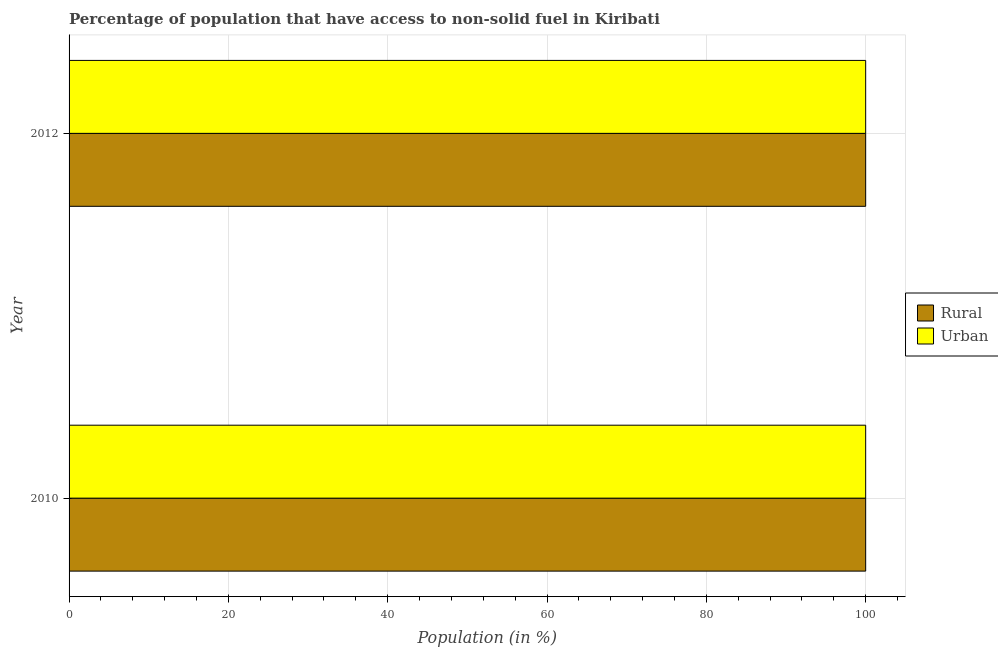How many different coloured bars are there?
Offer a terse response. 2. Are the number of bars per tick equal to the number of legend labels?
Make the answer very short. Yes. How many bars are there on the 1st tick from the bottom?
Keep it short and to the point. 2. What is the urban population in 2012?
Your answer should be very brief. 100. Across all years, what is the maximum urban population?
Offer a terse response. 100. Across all years, what is the minimum urban population?
Ensure brevity in your answer.  100. In which year was the urban population minimum?
Offer a terse response. 2010. What is the total urban population in the graph?
Your response must be concise. 200. What is the difference between the urban population in 2010 and the rural population in 2012?
Provide a succinct answer. 0. What is the average urban population per year?
Offer a terse response. 100. In how many years, is the rural population greater than 32 %?
Your answer should be compact. 2. What is the ratio of the rural population in 2010 to that in 2012?
Keep it short and to the point. 1. Is the difference between the rural population in 2010 and 2012 greater than the difference between the urban population in 2010 and 2012?
Ensure brevity in your answer.  No. What does the 1st bar from the top in 2010 represents?
Ensure brevity in your answer.  Urban. What does the 1st bar from the bottom in 2010 represents?
Provide a short and direct response. Rural. Are all the bars in the graph horizontal?
Make the answer very short. Yes. How many years are there in the graph?
Keep it short and to the point. 2. What is the difference between two consecutive major ticks on the X-axis?
Offer a terse response. 20. Are the values on the major ticks of X-axis written in scientific E-notation?
Give a very brief answer. No. Does the graph contain grids?
Offer a very short reply. Yes. How are the legend labels stacked?
Offer a terse response. Vertical. What is the title of the graph?
Your response must be concise. Percentage of population that have access to non-solid fuel in Kiribati. Does "Males" appear as one of the legend labels in the graph?
Keep it short and to the point. No. What is the label or title of the X-axis?
Make the answer very short. Population (in %). What is the label or title of the Y-axis?
Your response must be concise. Year. What is the Population (in %) in Rural in 2012?
Provide a short and direct response. 100. What is the Population (in %) of Urban in 2012?
Provide a succinct answer. 100. Across all years, what is the maximum Population (in %) of Rural?
Give a very brief answer. 100. Across all years, what is the minimum Population (in %) in Rural?
Give a very brief answer. 100. What is the total Population (in %) in Urban in the graph?
Your answer should be compact. 200. What is the difference between the Population (in %) of Rural in 2010 and that in 2012?
Offer a very short reply. 0. What is the average Population (in %) of Urban per year?
Provide a succinct answer. 100. In the year 2010, what is the difference between the Population (in %) in Rural and Population (in %) in Urban?
Provide a succinct answer. 0. In the year 2012, what is the difference between the Population (in %) of Rural and Population (in %) of Urban?
Provide a succinct answer. 0. What is the ratio of the Population (in %) of Rural in 2010 to that in 2012?
Offer a terse response. 1. What is the difference between the highest and the second highest Population (in %) of Urban?
Your answer should be very brief. 0. What is the difference between the highest and the lowest Population (in %) of Urban?
Keep it short and to the point. 0. 